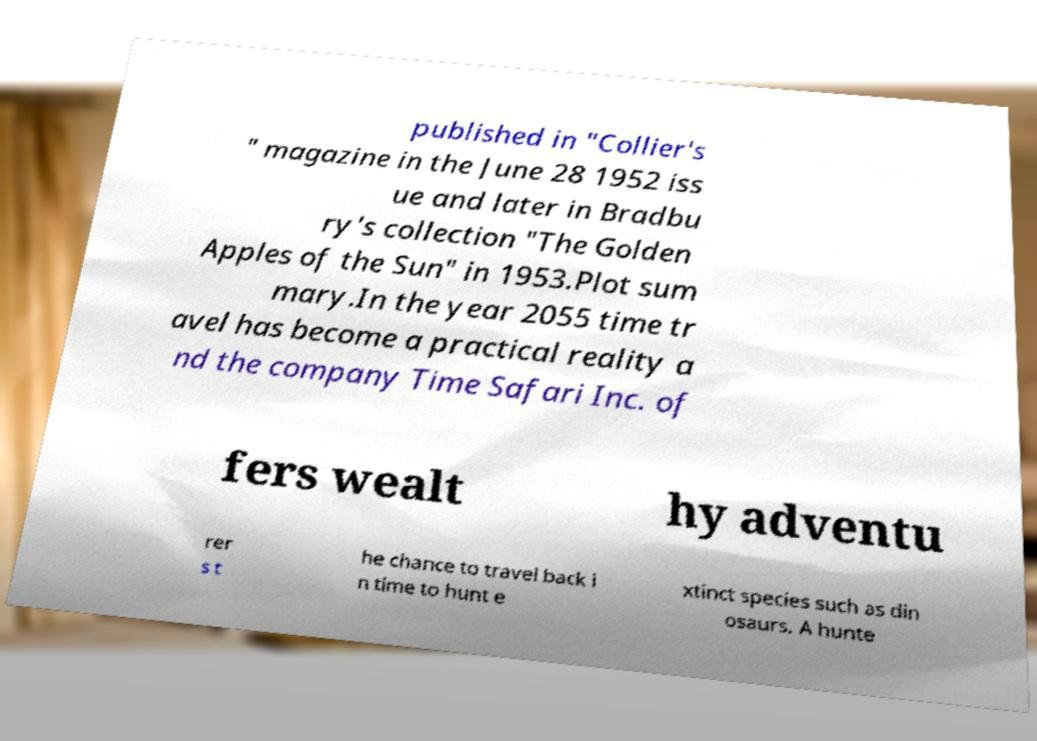For documentation purposes, I need the text within this image transcribed. Could you provide that? published in "Collier's " magazine in the June 28 1952 iss ue and later in Bradbu ry's collection "The Golden Apples of the Sun" in 1953.Plot sum mary.In the year 2055 time tr avel has become a practical reality a nd the company Time Safari Inc. of fers wealt hy adventu rer s t he chance to travel back i n time to hunt e xtinct species such as din osaurs. A hunte 